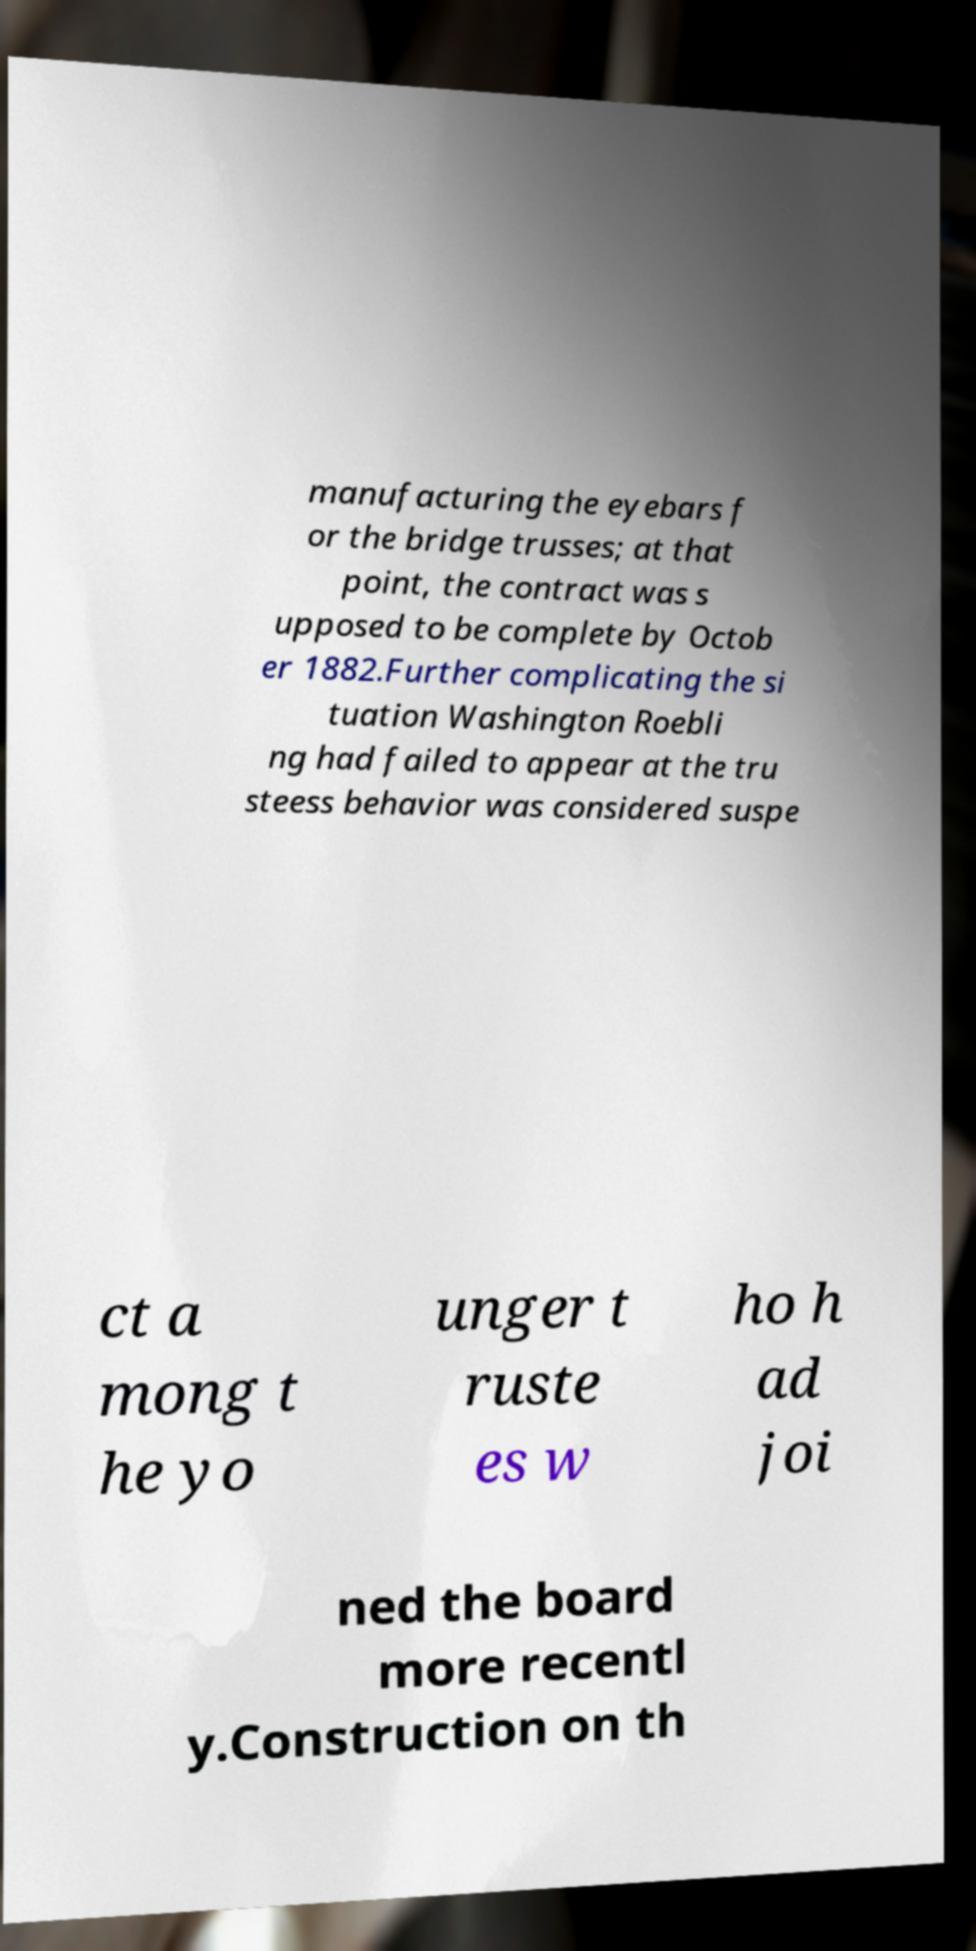Could you assist in decoding the text presented in this image and type it out clearly? manufacturing the eyebars f or the bridge trusses; at that point, the contract was s upposed to be complete by Octob er 1882.Further complicating the si tuation Washington Roebli ng had failed to appear at the tru steess behavior was considered suspe ct a mong t he yo unger t ruste es w ho h ad joi ned the board more recentl y.Construction on th 